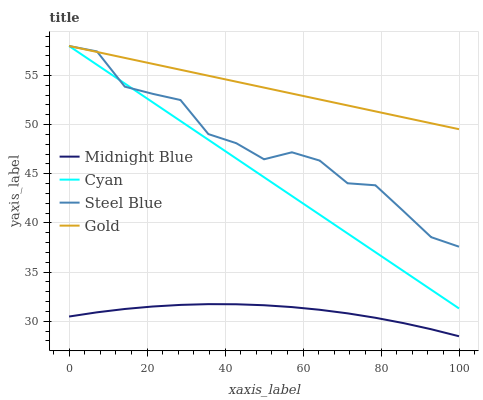Does Midnight Blue have the minimum area under the curve?
Answer yes or no. Yes. Does Gold have the maximum area under the curve?
Answer yes or no. Yes. Does Gold have the minimum area under the curve?
Answer yes or no. No. Does Midnight Blue have the maximum area under the curve?
Answer yes or no. No. Is Gold the smoothest?
Answer yes or no. Yes. Is Steel Blue the roughest?
Answer yes or no. Yes. Is Midnight Blue the smoothest?
Answer yes or no. No. Is Midnight Blue the roughest?
Answer yes or no. No. Does Midnight Blue have the lowest value?
Answer yes or no. Yes. Does Gold have the lowest value?
Answer yes or no. No. Does Steel Blue have the highest value?
Answer yes or no. Yes. Does Midnight Blue have the highest value?
Answer yes or no. No. Is Midnight Blue less than Steel Blue?
Answer yes or no. Yes. Is Steel Blue greater than Midnight Blue?
Answer yes or no. Yes. Does Gold intersect Cyan?
Answer yes or no. Yes. Is Gold less than Cyan?
Answer yes or no. No. Is Gold greater than Cyan?
Answer yes or no. No. Does Midnight Blue intersect Steel Blue?
Answer yes or no. No. 